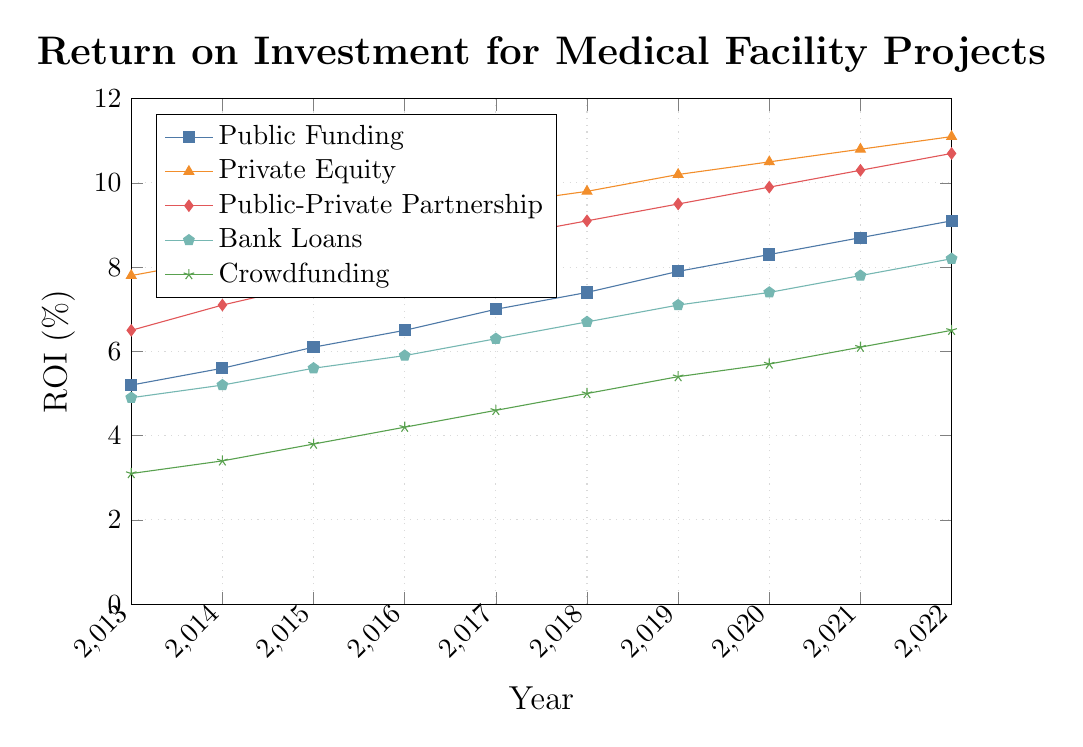What's the trend in ROI for projects funded by Public-Private Partnerships from 2013 to 2022? The ROI for Public-Private Partnerships shows a steady upward trend from 6.5% in 2013 to 10.7% in 2022. This indicates a consistent increase in ROI over the years.
Answer: Steady upward trend Which funding model had the highest ROI in 2022? In 2022, the ROI for Private Equity was the highest at 11.1%, surpassing the other funding models.
Answer: Private Equity Compare the ROI of Crowdfunding and Public-Private Partnership in 2015. In 2015, the ROI for Crowdfunding was 3.8% while for Public-Private Partnership it was 7.6%, indicating that Public-Private Partnership had a higher ROI than Crowdfunding.
Answer: Public-Private Partnership What is the average ROI for Bank Loans from 2013 to 2022? Sum the ROI values for Bank Loans from 2013 to 2022: (4.9 + 5.2 + 5.6 + 5.9 + 6.3 + 6.7 + 7.1 + 7.4 + 7.8 + 8.2) = 64.1. There are 10 years, so the average ROI is 64.1 / 10 = 6.41%.
Answer: 6.41% Which funding model showed the most significant consistent increase in ROI over the given period? By observing the slopes and increments of each funding model's ROI, Private Equity consistently exhibited significant increases, starting from 7.8% in 2013 and reaching 11.1% in 2022.
Answer: Private Equity Is there any year where Public Funding had a higher ROI compared to Crowdfunding? By comparing the ROI values for each year: Public Funding's lowest ROI was 5.2% in 2013, while Crowdfunding's highest was 6.5% in 2022. Therefore, Public Funding always had a higher ROI than Crowdfunding every year.
Answer: Yes, every year What is the percentile increase in ROI for Public Funding from 2013 to 2022? To find the percentile increase: ((9.1 - 5.2) / 5.2) * 100 = (3.9 / 5.2) * 100 ≈ 75%. So, the ROI for Public Funding increased by around 75% from 2013 to 2022.
Answer: 75% Between 2014 and 2017, which funding model saw the fastest increase in ROI? Calculate the differences for each model over these years and compare. 
Public Funding: 7.0 - 5.6 = 1.4
Private Equity: 9.5 - 8.2 = 1.3
Public-Private Partnership: 8.7 - 7.1 = 1.6
Bank Loans: 6.3 - 5.2 = 1.1
Crowdfunding: 4.6 - 3.4 = 1.2
Public-Private Partnership saw the fastest increase of 1.6%.
Answer: Public-Private Partnership Which funding model has the steepest slope of ROI increase between 2018 and 2022? Calculate the slope (change per year) for each model between these years.
Public Funding: (9.1 - 7.4) / 4 = 0.425
Private Equity: (11.1 - 9.8) / 4 = 0.325
Public-Private Partnership: (10.7 - 9.1) / 4 = 0.4
Bank Loans: (8.2 - 6.7) / 4 = 0.375
Crowdfunding: (6.5 - 5.0) / 4 = 0.375
Public Funding has the steepest slope of 0.425.
Answer: Public Funding How does the ROI of Bank Loans in 2020 compare to Crowdfunding in 2021? The ROI for Bank Loans in 2020 is 7.4%, while for Crowdfunding in 2021 it is 6.1%. Therefore, Bank Loans had a higher ROI compared to Crowdfunding.
Answer: Bank Loans 